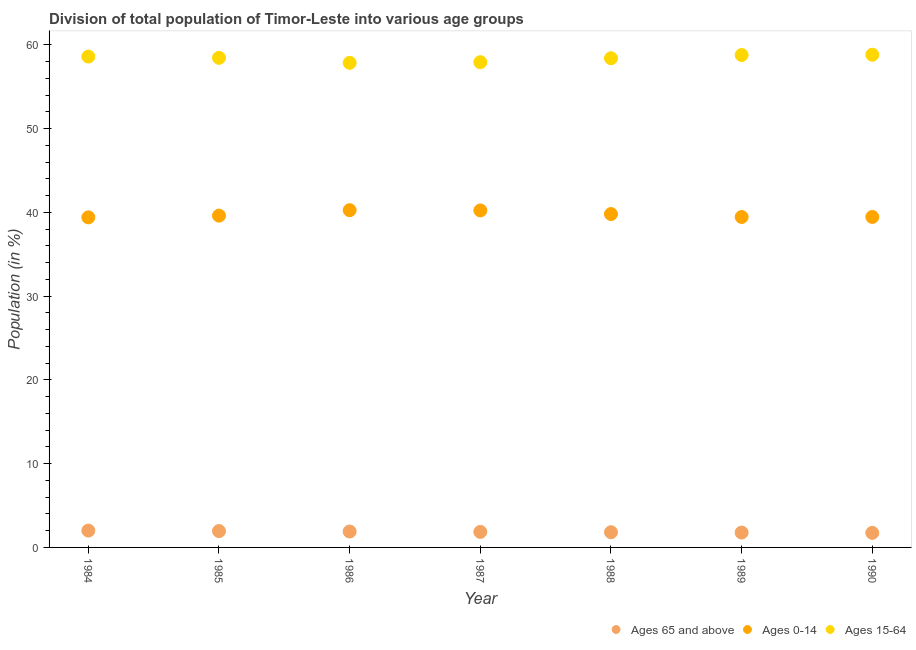How many different coloured dotlines are there?
Keep it short and to the point. 3. Is the number of dotlines equal to the number of legend labels?
Your response must be concise. Yes. What is the percentage of population within the age-group 0-14 in 1986?
Offer a very short reply. 40.26. Across all years, what is the maximum percentage of population within the age-group 0-14?
Provide a succinct answer. 40.26. Across all years, what is the minimum percentage of population within the age-group 0-14?
Provide a short and direct response. 39.4. What is the total percentage of population within the age-group 0-14 in the graph?
Your answer should be compact. 278.17. What is the difference between the percentage of population within the age-group 0-14 in 1984 and that in 1987?
Make the answer very short. -0.83. What is the difference between the percentage of population within the age-group of 65 and above in 1985 and the percentage of population within the age-group 0-14 in 1986?
Provide a succinct answer. -38.3. What is the average percentage of population within the age-group 0-14 per year?
Your answer should be very brief. 39.74. In the year 1987, what is the difference between the percentage of population within the age-group 15-64 and percentage of population within the age-group of 65 and above?
Keep it short and to the point. 56.07. What is the ratio of the percentage of population within the age-group 15-64 in 1984 to that in 1986?
Offer a very short reply. 1.01. Is the percentage of population within the age-group 15-64 in 1984 less than that in 1986?
Offer a very short reply. No. What is the difference between the highest and the second highest percentage of population within the age-group 0-14?
Your response must be concise. 0.03. What is the difference between the highest and the lowest percentage of population within the age-group 15-64?
Give a very brief answer. 0.97. In how many years, is the percentage of population within the age-group 15-64 greater than the average percentage of population within the age-group 15-64 taken over all years?
Your answer should be very brief. 4. Does the percentage of population within the age-group 0-14 monotonically increase over the years?
Your answer should be compact. No. Is the percentage of population within the age-group 0-14 strictly greater than the percentage of population within the age-group 15-64 over the years?
Provide a short and direct response. No. Are the values on the major ticks of Y-axis written in scientific E-notation?
Provide a short and direct response. No. Where does the legend appear in the graph?
Your response must be concise. Bottom right. What is the title of the graph?
Provide a succinct answer. Division of total population of Timor-Leste into various age groups
. Does "Ages 65 and above" appear as one of the legend labels in the graph?
Provide a short and direct response. Yes. What is the label or title of the X-axis?
Provide a succinct answer. Year. What is the Population (in %) in Ages 65 and above in 1984?
Ensure brevity in your answer.  2.01. What is the Population (in %) in Ages 0-14 in 1984?
Provide a short and direct response. 39.4. What is the Population (in %) of Ages 15-64 in 1984?
Your answer should be very brief. 58.59. What is the Population (in %) in Ages 65 and above in 1985?
Offer a terse response. 1.95. What is the Population (in %) in Ages 0-14 in 1985?
Provide a short and direct response. 39.6. What is the Population (in %) in Ages 15-64 in 1985?
Keep it short and to the point. 58.44. What is the Population (in %) of Ages 65 and above in 1986?
Keep it short and to the point. 1.9. What is the Population (in %) of Ages 0-14 in 1986?
Provide a succinct answer. 40.26. What is the Population (in %) of Ages 15-64 in 1986?
Offer a very short reply. 57.85. What is the Population (in %) of Ages 65 and above in 1987?
Give a very brief answer. 1.85. What is the Population (in %) of Ages 0-14 in 1987?
Make the answer very short. 40.23. What is the Population (in %) in Ages 15-64 in 1987?
Make the answer very short. 57.92. What is the Population (in %) in Ages 65 and above in 1988?
Ensure brevity in your answer.  1.81. What is the Population (in %) in Ages 0-14 in 1988?
Give a very brief answer. 39.79. What is the Population (in %) in Ages 15-64 in 1988?
Make the answer very short. 58.39. What is the Population (in %) in Ages 65 and above in 1989?
Your answer should be compact. 1.78. What is the Population (in %) in Ages 0-14 in 1989?
Make the answer very short. 39.44. What is the Population (in %) of Ages 15-64 in 1989?
Provide a short and direct response. 58.78. What is the Population (in %) of Ages 65 and above in 1990?
Make the answer very short. 1.74. What is the Population (in %) of Ages 0-14 in 1990?
Provide a short and direct response. 39.45. What is the Population (in %) of Ages 15-64 in 1990?
Provide a succinct answer. 58.81. Across all years, what is the maximum Population (in %) of Ages 65 and above?
Keep it short and to the point. 2.01. Across all years, what is the maximum Population (in %) of Ages 0-14?
Give a very brief answer. 40.26. Across all years, what is the maximum Population (in %) of Ages 15-64?
Your answer should be very brief. 58.81. Across all years, what is the minimum Population (in %) in Ages 65 and above?
Offer a terse response. 1.74. Across all years, what is the minimum Population (in %) of Ages 0-14?
Make the answer very short. 39.4. Across all years, what is the minimum Population (in %) of Ages 15-64?
Keep it short and to the point. 57.85. What is the total Population (in %) of Ages 65 and above in the graph?
Offer a terse response. 13.04. What is the total Population (in %) in Ages 0-14 in the graph?
Provide a succinct answer. 278.17. What is the total Population (in %) in Ages 15-64 in the graph?
Your answer should be compact. 408.79. What is the difference between the Population (in %) in Ages 65 and above in 1984 and that in 1985?
Give a very brief answer. 0.06. What is the difference between the Population (in %) of Ages 0-14 in 1984 and that in 1985?
Give a very brief answer. -0.21. What is the difference between the Population (in %) of Ages 15-64 in 1984 and that in 1985?
Your answer should be compact. 0.15. What is the difference between the Population (in %) in Ages 65 and above in 1984 and that in 1986?
Offer a very short reply. 0.11. What is the difference between the Population (in %) in Ages 0-14 in 1984 and that in 1986?
Provide a short and direct response. -0.86. What is the difference between the Population (in %) of Ages 15-64 in 1984 and that in 1986?
Ensure brevity in your answer.  0.75. What is the difference between the Population (in %) of Ages 65 and above in 1984 and that in 1987?
Give a very brief answer. 0.16. What is the difference between the Population (in %) in Ages 0-14 in 1984 and that in 1987?
Offer a terse response. -0.83. What is the difference between the Population (in %) of Ages 15-64 in 1984 and that in 1987?
Provide a succinct answer. 0.67. What is the difference between the Population (in %) of Ages 65 and above in 1984 and that in 1988?
Your answer should be very brief. 0.2. What is the difference between the Population (in %) in Ages 0-14 in 1984 and that in 1988?
Your answer should be compact. -0.4. What is the difference between the Population (in %) of Ages 15-64 in 1984 and that in 1988?
Offer a terse response. 0.2. What is the difference between the Population (in %) in Ages 65 and above in 1984 and that in 1989?
Your answer should be compact. 0.23. What is the difference between the Population (in %) in Ages 0-14 in 1984 and that in 1989?
Provide a short and direct response. -0.05. What is the difference between the Population (in %) of Ages 15-64 in 1984 and that in 1989?
Offer a terse response. -0.19. What is the difference between the Population (in %) in Ages 65 and above in 1984 and that in 1990?
Give a very brief answer. 0.27. What is the difference between the Population (in %) of Ages 0-14 in 1984 and that in 1990?
Provide a succinct answer. -0.05. What is the difference between the Population (in %) of Ages 15-64 in 1984 and that in 1990?
Your response must be concise. -0.22. What is the difference between the Population (in %) in Ages 65 and above in 1985 and that in 1986?
Keep it short and to the point. 0.06. What is the difference between the Population (in %) in Ages 0-14 in 1985 and that in 1986?
Give a very brief answer. -0.65. What is the difference between the Population (in %) of Ages 15-64 in 1985 and that in 1986?
Give a very brief answer. 0.6. What is the difference between the Population (in %) of Ages 65 and above in 1985 and that in 1987?
Provide a succinct answer. 0.1. What is the difference between the Population (in %) in Ages 0-14 in 1985 and that in 1987?
Make the answer very short. -0.62. What is the difference between the Population (in %) of Ages 15-64 in 1985 and that in 1987?
Give a very brief answer. 0.52. What is the difference between the Population (in %) in Ages 65 and above in 1985 and that in 1988?
Give a very brief answer. 0.14. What is the difference between the Population (in %) of Ages 0-14 in 1985 and that in 1988?
Your response must be concise. -0.19. What is the difference between the Population (in %) of Ages 15-64 in 1985 and that in 1988?
Make the answer very short. 0.05. What is the difference between the Population (in %) in Ages 65 and above in 1985 and that in 1989?
Ensure brevity in your answer.  0.18. What is the difference between the Population (in %) of Ages 0-14 in 1985 and that in 1989?
Give a very brief answer. 0.16. What is the difference between the Population (in %) of Ages 15-64 in 1985 and that in 1989?
Offer a terse response. -0.34. What is the difference between the Population (in %) of Ages 65 and above in 1985 and that in 1990?
Keep it short and to the point. 0.21. What is the difference between the Population (in %) in Ages 0-14 in 1985 and that in 1990?
Give a very brief answer. 0.16. What is the difference between the Population (in %) of Ages 15-64 in 1985 and that in 1990?
Offer a terse response. -0.37. What is the difference between the Population (in %) in Ages 65 and above in 1986 and that in 1987?
Ensure brevity in your answer.  0.05. What is the difference between the Population (in %) in Ages 0-14 in 1986 and that in 1987?
Your response must be concise. 0.03. What is the difference between the Population (in %) in Ages 15-64 in 1986 and that in 1987?
Provide a short and direct response. -0.08. What is the difference between the Population (in %) in Ages 65 and above in 1986 and that in 1988?
Offer a terse response. 0.08. What is the difference between the Population (in %) in Ages 0-14 in 1986 and that in 1988?
Make the answer very short. 0.46. What is the difference between the Population (in %) of Ages 15-64 in 1986 and that in 1988?
Your answer should be very brief. -0.55. What is the difference between the Population (in %) in Ages 65 and above in 1986 and that in 1989?
Offer a very short reply. 0.12. What is the difference between the Population (in %) in Ages 0-14 in 1986 and that in 1989?
Ensure brevity in your answer.  0.81. What is the difference between the Population (in %) in Ages 15-64 in 1986 and that in 1989?
Offer a terse response. -0.93. What is the difference between the Population (in %) of Ages 65 and above in 1986 and that in 1990?
Offer a terse response. 0.16. What is the difference between the Population (in %) of Ages 0-14 in 1986 and that in 1990?
Your answer should be compact. 0.81. What is the difference between the Population (in %) of Ages 15-64 in 1986 and that in 1990?
Provide a short and direct response. -0.97. What is the difference between the Population (in %) in Ages 65 and above in 1987 and that in 1988?
Your answer should be very brief. 0.04. What is the difference between the Population (in %) in Ages 0-14 in 1987 and that in 1988?
Provide a succinct answer. 0.43. What is the difference between the Population (in %) of Ages 15-64 in 1987 and that in 1988?
Your answer should be very brief. -0.47. What is the difference between the Population (in %) in Ages 65 and above in 1987 and that in 1989?
Your answer should be compact. 0.08. What is the difference between the Population (in %) in Ages 0-14 in 1987 and that in 1989?
Provide a succinct answer. 0.78. What is the difference between the Population (in %) of Ages 15-64 in 1987 and that in 1989?
Ensure brevity in your answer.  -0.86. What is the difference between the Population (in %) of Ages 65 and above in 1987 and that in 1990?
Your answer should be very brief. 0.11. What is the difference between the Population (in %) in Ages 0-14 in 1987 and that in 1990?
Your answer should be very brief. 0.78. What is the difference between the Population (in %) of Ages 15-64 in 1987 and that in 1990?
Ensure brevity in your answer.  -0.89. What is the difference between the Population (in %) of Ages 65 and above in 1988 and that in 1989?
Keep it short and to the point. 0.04. What is the difference between the Population (in %) in Ages 0-14 in 1988 and that in 1989?
Provide a short and direct response. 0.35. What is the difference between the Population (in %) in Ages 15-64 in 1988 and that in 1989?
Keep it short and to the point. -0.39. What is the difference between the Population (in %) in Ages 65 and above in 1988 and that in 1990?
Give a very brief answer. 0.07. What is the difference between the Population (in %) in Ages 0-14 in 1988 and that in 1990?
Give a very brief answer. 0.35. What is the difference between the Population (in %) in Ages 15-64 in 1988 and that in 1990?
Offer a terse response. -0.42. What is the difference between the Population (in %) in Ages 65 and above in 1989 and that in 1990?
Provide a short and direct response. 0.04. What is the difference between the Population (in %) in Ages 0-14 in 1989 and that in 1990?
Ensure brevity in your answer.  -0.01. What is the difference between the Population (in %) of Ages 15-64 in 1989 and that in 1990?
Give a very brief answer. -0.03. What is the difference between the Population (in %) in Ages 65 and above in 1984 and the Population (in %) in Ages 0-14 in 1985?
Ensure brevity in your answer.  -37.59. What is the difference between the Population (in %) in Ages 65 and above in 1984 and the Population (in %) in Ages 15-64 in 1985?
Your response must be concise. -56.43. What is the difference between the Population (in %) of Ages 0-14 in 1984 and the Population (in %) of Ages 15-64 in 1985?
Give a very brief answer. -19.04. What is the difference between the Population (in %) in Ages 65 and above in 1984 and the Population (in %) in Ages 0-14 in 1986?
Keep it short and to the point. -38.25. What is the difference between the Population (in %) of Ages 65 and above in 1984 and the Population (in %) of Ages 15-64 in 1986?
Keep it short and to the point. -55.84. What is the difference between the Population (in %) of Ages 0-14 in 1984 and the Population (in %) of Ages 15-64 in 1986?
Provide a succinct answer. -18.45. What is the difference between the Population (in %) of Ages 65 and above in 1984 and the Population (in %) of Ages 0-14 in 1987?
Your answer should be very brief. -38.22. What is the difference between the Population (in %) of Ages 65 and above in 1984 and the Population (in %) of Ages 15-64 in 1987?
Your response must be concise. -55.91. What is the difference between the Population (in %) in Ages 0-14 in 1984 and the Population (in %) in Ages 15-64 in 1987?
Keep it short and to the point. -18.52. What is the difference between the Population (in %) of Ages 65 and above in 1984 and the Population (in %) of Ages 0-14 in 1988?
Offer a very short reply. -37.78. What is the difference between the Population (in %) of Ages 65 and above in 1984 and the Population (in %) of Ages 15-64 in 1988?
Provide a succinct answer. -56.38. What is the difference between the Population (in %) in Ages 0-14 in 1984 and the Population (in %) in Ages 15-64 in 1988?
Provide a succinct answer. -18.99. What is the difference between the Population (in %) of Ages 65 and above in 1984 and the Population (in %) of Ages 0-14 in 1989?
Your response must be concise. -37.43. What is the difference between the Population (in %) in Ages 65 and above in 1984 and the Population (in %) in Ages 15-64 in 1989?
Your answer should be compact. -56.77. What is the difference between the Population (in %) of Ages 0-14 in 1984 and the Population (in %) of Ages 15-64 in 1989?
Offer a very short reply. -19.38. What is the difference between the Population (in %) of Ages 65 and above in 1984 and the Population (in %) of Ages 0-14 in 1990?
Provide a short and direct response. -37.44. What is the difference between the Population (in %) in Ages 65 and above in 1984 and the Population (in %) in Ages 15-64 in 1990?
Offer a very short reply. -56.8. What is the difference between the Population (in %) in Ages 0-14 in 1984 and the Population (in %) in Ages 15-64 in 1990?
Your answer should be compact. -19.41. What is the difference between the Population (in %) of Ages 65 and above in 1985 and the Population (in %) of Ages 0-14 in 1986?
Ensure brevity in your answer.  -38.3. What is the difference between the Population (in %) of Ages 65 and above in 1985 and the Population (in %) of Ages 15-64 in 1986?
Provide a short and direct response. -55.89. What is the difference between the Population (in %) of Ages 0-14 in 1985 and the Population (in %) of Ages 15-64 in 1986?
Ensure brevity in your answer.  -18.24. What is the difference between the Population (in %) of Ages 65 and above in 1985 and the Population (in %) of Ages 0-14 in 1987?
Provide a short and direct response. -38.27. What is the difference between the Population (in %) in Ages 65 and above in 1985 and the Population (in %) in Ages 15-64 in 1987?
Your answer should be very brief. -55.97. What is the difference between the Population (in %) in Ages 0-14 in 1985 and the Population (in %) in Ages 15-64 in 1987?
Give a very brief answer. -18.32. What is the difference between the Population (in %) of Ages 65 and above in 1985 and the Population (in %) of Ages 0-14 in 1988?
Your response must be concise. -37.84. What is the difference between the Population (in %) in Ages 65 and above in 1985 and the Population (in %) in Ages 15-64 in 1988?
Ensure brevity in your answer.  -56.44. What is the difference between the Population (in %) of Ages 0-14 in 1985 and the Population (in %) of Ages 15-64 in 1988?
Offer a terse response. -18.79. What is the difference between the Population (in %) of Ages 65 and above in 1985 and the Population (in %) of Ages 0-14 in 1989?
Your answer should be very brief. -37.49. What is the difference between the Population (in %) of Ages 65 and above in 1985 and the Population (in %) of Ages 15-64 in 1989?
Your answer should be compact. -56.83. What is the difference between the Population (in %) of Ages 0-14 in 1985 and the Population (in %) of Ages 15-64 in 1989?
Offer a very short reply. -19.18. What is the difference between the Population (in %) of Ages 65 and above in 1985 and the Population (in %) of Ages 0-14 in 1990?
Your answer should be very brief. -37.5. What is the difference between the Population (in %) of Ages 65 and above in 1985 and the Population (in %) of Ages 15-64 in 1990?
Provide a short and direct response. -56.86. What is the difference between the Population (in %) of Ages 0-14 in 1985 and the Population (in %) of Ages 15-64 in 1990?
Make the answer very short. -19.21. What is the difference between the Population (in %) of Ages 65 and above in 1986 and the Population (in %) of Ages 0-14 in 1987?
Make the answer very short. -38.33. What is the difference between the Population (in %) in Ages 65 and above in 1986 and the Population (in %) in Ages 15-64 in 1987?
Give a very brief answer. -56.02. What is the difference between the Population (in %) of Ages 0-14 in 1986 and the Population (in %) of Ages 15-64 in 1987?
Provide a succinct answer. -17.67. What is the difference between the Population (in %) in Ages 65 and above in 1986 and the Population (in %) in Ages 0-14 in 1988?
Provide a succinct answer. -37.9. What is the difference between the Population (in %) of Ages 65 and above in 1986 and the Population (in %) of Ages 15-64 in 1988?
Give a very brief answer. -56.49. What is the difference between the Population (in %) of Ages 0-14 in 1986 and the Population (in %) of Ages 15-64 in 1988?
Give a very brief answer. -18.14. What is the difference between the Population (in %) in Ages 65 and above in 1986 and the Population (in %) in Ages 0-14 in 1989?
Provide a succinct answer. -37.55. What is the difference between the Population (in %) of Ages 65 and above in 1986 and the Population (in %) of Ages 15-64 in 1989?
Your answer should be compact. -56.88. What is the difference between the Population (in %) in Ages 0-14 in 1986 and the Population (in %) in Ages 15-64 in 1989?
Provide a succinct answer. -18.52. What is the difference between the Population (in %) in Ages 65 and above in 1986 and the Population (in %) in Ages 0-14 in 1990?
Your response must be concise. -37.55. What is the difference between the Population (in %) in Ages 65 and above in 1986 and the Population (in %) in Ages 15-64 in 1990?
Provide a succinct answer. -56.91. What is the difference between the Population (in %) of Ages 0-14 in 1986 and the Population (in %) of Ages 15-64 in 1990?
Provide a short and direct response. -18.56. What is the difference between the Population (in %) of Ages 65 and above in 1987 and the Population (in %) of Ages 0-14 in 1988?
Give a very brief answer. -37.94. What is the difference between the Population (in %) in Ages 65 and above in 1987 and the Population (in %) in Ages 15-64 in 1988?
Your answer should be compact. -56.54. What is the difference between the Population (in %) of Ages 0-14 in 1987 and the Population (in %) of Ages 15-64 in 1988?
Ensure brevity in your answer.  -18.17. What is the difference between the Population (in %) of Ages 65 and above in 1987 and the Population (in %) of Ages 0-14 in 1989?
Ensure brevity in your answer.  -37.59. What is the difference between the Population (in %) of Ages 65 and above in 1987 and the Population (in %) of Ages 15-64 in 1989?
Keep it short and to the point. -56.93. What is the difference between the Population (in %) in Ages 0-14 in 1987 and the Population (in %) in Ages 15-64 in 1989?
Your answer should be very brief. -18.55. What is the difference between the Population (in %) in Ages 65 and above in 1987 and the Population (in %) in Ages 0-14 in 1990?
Offer a very short reply. -37.6. What is the difference between the Population (in %) of Ages 65 and above in 1987 and the Population (in %) of Ages 15-64 in 1990?
Your answer should be very brief. -56.96. What is the difference between the Population (in %) of Ages 0-14 in 1987 and the Population (in %) of Ages 15-64 in 1990?
Offer a very short reply. -18.59. What is the difference between the Population (in %) of Ages 65 and above in 1988 and the Population (in %) of Ages 0-14 in 1989?
Provide a succinct answer. -37.63. What is the difference between the Population (in %) of Ages 65 and above in 1988 and the Population (in %) of Ages 15-64 in 1989?
Your answer should be compact. -56.97. What is the difference between the Population (in %) of Ages 0-14 in 1988 and the Population (in %) of Ages 15-64 in 1989?
Ensure brevity in your answer.  -18.99. What is the difference between the Population (in %) of Ages 65 and above in 1988 and the Population (in %) of Ages 0-14 in 1990?
Offer a very short reply. -37.63. What is the difference between the Population (in %) in Ages 65 and above in 1988 and the Population (in %) in Ages 15-64 in 1990?
Your response must be concise. -57. What is the difference between the Population (in %) of Ages 0-14 in 1988 and the Population (in %) of Ages 15-64 in 1990?
Give a very brief answer. -19.02. What is the difference between the Population (in %) in Ages 65 and above in 1989 and the Population (in %) in Ages 0-14 in 1990?
Provide a succinct answer. -37.67. What is the difference between the Population (in %) of Ages 65 and above in 1989 and the Population (in %) of Ages 15-64 in 1990?
Your response must be concise. -57.04. What is the difference between the Population (in %) in Ages 0-14 in 1989 and the Population (in %) in Ages 15-64 in 1990?
Make the answer very short. -19.37. What is the average Population (in %) of Ages 65 and above per year?
Your response must be concise. 1.86. What is the average Population (in %) in Ages 0-14 per year?
Offer a very short reply. 39.74. What is the average Population (in %) in Ages 15-64 per year?
Ensure brevity in your answer.  58.4. In the year 1984, what is the difference between the Population (in %) in Ages 65 and above and Population (in %) in Ages 0-14?
Ensure brevity in your answer.  -37.39. In the year 1984, what is the difference between the Population (in %) of Ages 65 and above and Population (in %) of Ages 15-64?
Your answer should be compact. -56.58. In the year 1984, what is the difference between the Population (in %) in Ages 0-14 and Population (in %) in Ages 15-64?
Provide a succinct answer. -19.19. In the year 1985, what is the difference between the Population (in %) in Ages 65 and above and Population (in %) in Ages 0-14?
Ensure brevity in your answer.  -37.65. In the year 1985, what is the difference between the Population (in %) in Ages 65 and above and Population (in %) in Ages 15-64?
Give a very brief answer. -56.49. In the year 1985, what is the difference between the Population (in %) of Ages 0-14 and Population (in %) of Ages 15-64?
Keep it short and to the point. -18.84. In the year 1986, what is the difference between the Population (in %) in Ages 65 and above and Population (in %) in Ages 0-14?
Your response must be concise. -38.36. In the year 1986, what is the difference between the Population (in %) in Ages 65 and above and Population (in %) in Ages 15-64?
Ensure brevity in your answer.  -55.95. In the year 1986, what is the difference between the Population (in %) of Ages 0-14 and Population (in %) of Ages 15-64?
Give a very brief answer. -17.59. In the year 1987, what is the difference between the Population (in %) of Ages 65 and above and Population (in %) of Ages 0-14?
Your response must be concise. -38.37. In the year 1987, what is the difference between the Population (in %) in Ages 65 and above and Population (in %) in Ages 15-64?
Your answer should be very brief. -56.07. In the year 1987, what is the difference between the Population (in %) of Ages 0-14 and Population (in %) of Ages 15-64?
Your answer should be compact. -17.7. In the year 1988, what is the difference between the Population (in %) in Ages 65 and above and Population (in %) in Ages 0-14?
Give a very brief answer. -37.98. In the year 1988, what is the difference between the Population (in %) of Ages 65 and above and Population (in %) of Ages 15-64?
Make the answer very short. -56.58. In the year 1988, what is the difference between the Population (in %) in Ages 0-14 and Population (in %) in Ages 15-64?
Provide a succinct answer. -18.6. In the year 1989, what is the difference between the Population (in %) in Ages 65 and above and Population (in %) in Ages 0-14?
Provide a succinct answer. -37.67. In the year 1989, what is the difference between the Population (in %) of Ages 65 and above and Population (in %) of Ages 15-64?
Offer a terse response. -57. In the year 1989, what is the difference between the Population (in %) in Ages 0-14 and Population (in %) in Ages 15-64?
Provide a succinct answer. -19.34. In the year 1990, what is the difference between the Population (in %) of Ages 65 and above and Population (in %) of Ages 0-14?
Offer a very short reply. -37.71. In the year 1990, what is the difference between the Population (in %) of Ages 65 and above and Population (in %) of Ages 15-64?
Provide a succinct answer. -57.07. In the year 1990, what is the difference between the Population (in %) in Ages 0-14 and Population (in %) in Ages 15-64?
Provide a succinct answer. -19.36. What is the ratio of the Population (in %) in Ages 65 and above in 1984 to that in 1985?
Provide a succinct answer. 1.03. What is the ratio of the Population (in %) in Ages 15-64 in 1984 to that in 1985?
Keep it short and to the point. 1. What is the ratio of the Population (in %) of Ages 65 and above in 1984 to that in 1986?
Provide a short and direct response. 1.06. What is the ratio of the Population (in %) in Ages 0-14 in 1984 to that in 1986?
Offer a very short reply. 0.98. What is the ratio of the Population (in %) of Ages 15-64 in 1984 to that in 1986?
Your response must be concise. 1.01. What is the ratio of the Population (in %) of Ages 65 and above in 1984 to that in 1987?
Provide a short and direct response. 1.08. What is the ratio of the Population (in %) in Ages 0-14 in 1984 to that in 1987?
Ensure brevity in your answer.  0.98. What is the ratio of the Population (in %) of Ages 15-64 in 1984 to that in 1987?
Your answer should be very brief. 1.01. What is the ratio of the Population (in %) of Ages 65 and above in 1984 to that in 1988?
Offer a very short reply. 1.11. What is the ratio of the Population (in %) of Ages 65 and above in 1984 to that in 1989?
Give a very brief answer. 1.13. What is the ratio of the Population (in %) in Ages 65 and above in 1984 to that in 1990?
Your answer should be very brief. 1.16. What is the ratio of the Population (in %) of Ages 0-14 in 1984 to that in 1990?
Provide a short and direct response. 1. What is the ratio of the Population (in %) of Ages 15-64 in 1984 to that in 1990?
Ensure brevity in your answer.  1. What is the ratio of the Population (in %) in Ages 0-14 in 1985 to that in 1986?
Offer a very short reply. 0.98. What is the ratio of the Population (in %) in Ages 15-64 in 1985 to that in 1986?
Give a very brief answer. 1.01. What is the ratio of the Population (in %) of Ages 65 and above in 1985 to that in 1987?
Your response must be concise. 1.05. What is the ratio of the Population (in %) in Ages 0-14 in 1985 to that in 1987?
Provide a short and direct response. 0.98. What is the ratio of the Population (in %) of Ages 15-64 in 1985 to that in 1987?
Keep it short and to the point. 1.01. What is the ratio of the Population (in %) in Ages 65 and above in 1985 to that in 1988?
Your response must be concise. 1.08. What is the ratio of the Population (in %) in Ages 0-14 in 1985 to that in 1988?
Your answer should be compact. 1. What is the ratio of the Population (in %) of Ages 65 and above in 1985 to that in 1989?
Provide a short and direct response. 1.1. What is the ratio of the Population (in %) in Ages 0-14 in 1985 to that in 1989?
Ensure brevity in your answer.  1. What is the ratio of the Population (in %) of Ages 15-64 in 1985 to that in 1989?
Offer a very short reply. 0.99. What is the ratio of the Population (in %) of Ages 65 and above in 1985 to that in 1990?
Ensure brevity in your answer.  1.12. What is the ratio of the Population (in %) in Ages 65 and above in 1986 to that in 1987?
Offer a terse response. 1.02. What is the ratio of the Population (in %) of Ages 0-14 in 1986 to that in 1987?
Offer a terse response. 1. What is the ratio of the Population (in %) of Ages 65 and above in 1986 to that in 1988?
Provide a short and direct response. 1.05. What is the ratio of the Population (in %) of Ages 0-14 in 1986 to that in 1988?
Give a very brief answer. 1.01. What is the ratio of the Population (in %) of Ages 15-64 in 1986 to that in 1988?
Make the answer very short. 0.99. What is the ratio of the Population (in %) in Ages 65 and above in 1986 to that in 1989?
Your answer should be compact. 1.07. What is the ratio of the Population (in %) in Ages 0-14 in 1986 to that in 1989?
Your answer should be compact. 1.02. What is the ratio of the Population (in %) in Ages 15-64 in 1986 to that in 1989?
Your answer should be very brief. 0.98. What is the ratio of the Population (in %) of Ages 65 and above in 1986 to that in 1990?
Keep it short and to the point. 1.09. What is the ratio of the Population (in %) in Ages 0-14 in 1986 to that in 1990?
Offer a terse response. 1.02. What is the ratio of the Population (in %) in Ages 15-64 in 1986 to that in 1990?
Ensure brevity in your answer.  0.98. What is the ratio of the Population (in %) of Ages 65 and above in 1987 to that in 1988?
Your answer should be very brief. 1.02. What is the ratio of the Population (in %) of Ages 0-14 in 1987 to that in 1988?
Your answer should be very brief. 1.01. What is the ratio of the Population (in %) in Ages 65 and above in 1987 to that in 1989?
Provide a succinct answer. 1.04. What is the ratio of the Population (in %) of Ages 0-14 in 1987 to that in 1989?
Your answer should be very brief. 1.02. What is the ratio of the Population (in %) in Ages 15-64 in 1987 to that in 1989?
Ensure brevity in your answer.  0.99. What is the ratio of the Population (in %) in Ages 65 and above in 1987 to that in 1990?
Offer a very short reply. 1.07. What is the ratio of the Population (in %) of Ages 0-14 in 1987 to that in 1990?
Give a very brief answer. 1.02. What is the ratio of the Population (in %) of Ages 15-64 in 1987 to that in 1990?
Give a very brief answer. 0.98. What is the ratio of the Population (in %) of Ages 65 and above in 1988 to that in 1989?
Offer a very short reply. 1.02. What is the ratio of the Population (in %) in Ages 0-14 in 1988 to that in 1989?
Provide a short and direct response. 1.01. What is the ratio of the Population (in %) of Ages 65 and above in 1988 to that in 1990?
Make the answer very short. 1.04. What is the ratio of the Population (in %) of Ages 0-14 in 1988 to that in 1990?
Make the answer very short. 1.01. What is the ratio of the Population (in %) in Ages 15-64 in 1988 to that in 1990?
Make the answer very short. 0.99. What is the ratio of the Population (in %) of Ages 65 and above in 1989 to that in 1990?
Offer a terse response. 1.02. What is the ratio of the Population (in %) in Ages 0-14 in 1989 to that in 1990?
Offer a very short reply. 1. What is the difference between the highest and the second highest Population (in %) of Ages 65 and above?
Provide a succinct answer. 0.06. What is the difference between the highest and the second highest Population (in %) in Ages 0-14?
Your response must be concise. 0.03. What is the difference between the highest and the second highest Population (in %) in Ages 15-64?
Your answer should be very brief. 0.03. What is the difference between the highest and the lowest Population (in %) in Ages 65 and above?
Offer a very short reply. 0.27. What is the difference between the highest and the lowest Population (in %) of Ages 0-14?
Your answer should be compact. 0.86. What is the difference between the highest and the lowest Population (in %) of Ages 15-64?
Provide a short and direct response. 0.97. 